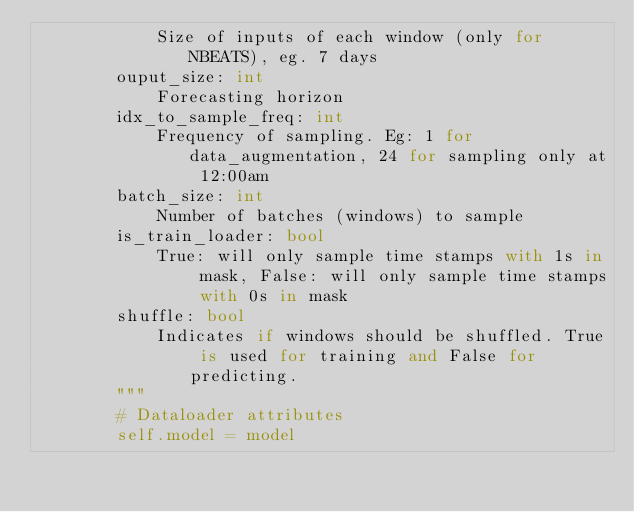Convert code to text. <code><loc_0><loc_0><loc_500><loc_500><_Python_>            Size of inputs of each window (only for NBEATS), eg. 7 days
        ouput_size: int
            Forecasting horizon
        idx_to_sample_freq: int
            Frequency of sampling. Eg: 1 for data_augmentation, 24 for sampling only at 12:00am
        batch_size: int
            Number of batches (windows) to sample
        is_train_loader: bool
            True: will only sample time stamps with 1s in mask, False: will only sample time stamps with 0s in mask
        shuffle: bool
            Indicates if windows should be shuffled. True is used for training and False for predicting.
        """
        # Dataloader attributes
        self.model = model</code> 